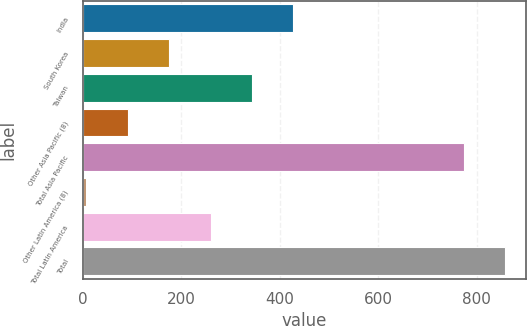<chart> <loc_0><loc_0><loc_500><loc_500><bar_chart><fcel>India<fcel>South Korea<fcel>Taiwan<fcel>Other Asia Pacific (8)<fcel>Total Asia Pacific<fcel>Other Latin America (8)<fcel>Total Latin America<fcel>Total<nl><fcel>427.5<fcel>175.2<fcel>343.4<fcel>91.1<fcel>774<fcel>7<fcel>259.3<fcel>858.1<nl></chart> 